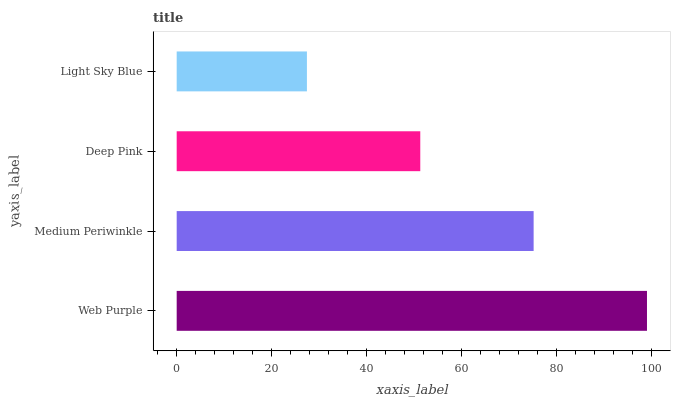Is Light Sky Blue the minimum?
Answer yes or no. Yes. Is Web Purple the maximum?
Answer yes or no. Yes. Is Medium Periwinkle the minimum?
Answer yes or no. No. Is Medium Periwinkle the maximum?
Answer yes or no. No. Is Web Purple greater than Medium Periwinkle?
Answer yes or no. Yes. Is Medium Periwinkle less than Web Purple?
Answer yes or no. Yes. Is Medium Periwinkle greater than Web Purple?
Answer yes or no. No. Is Web Purple less than Medium Periwinkle?
Answer yes or no. No. Is Medium Periwinkle the high median?
Answer yes or no. Yes. Is Deep Pink the low median?
Answer yes or no. Yes. Is Light Sky Blue the high median?
Answer yes or no. No. Is Medium Periwinkle the low median?
Answer yes or no. No. 